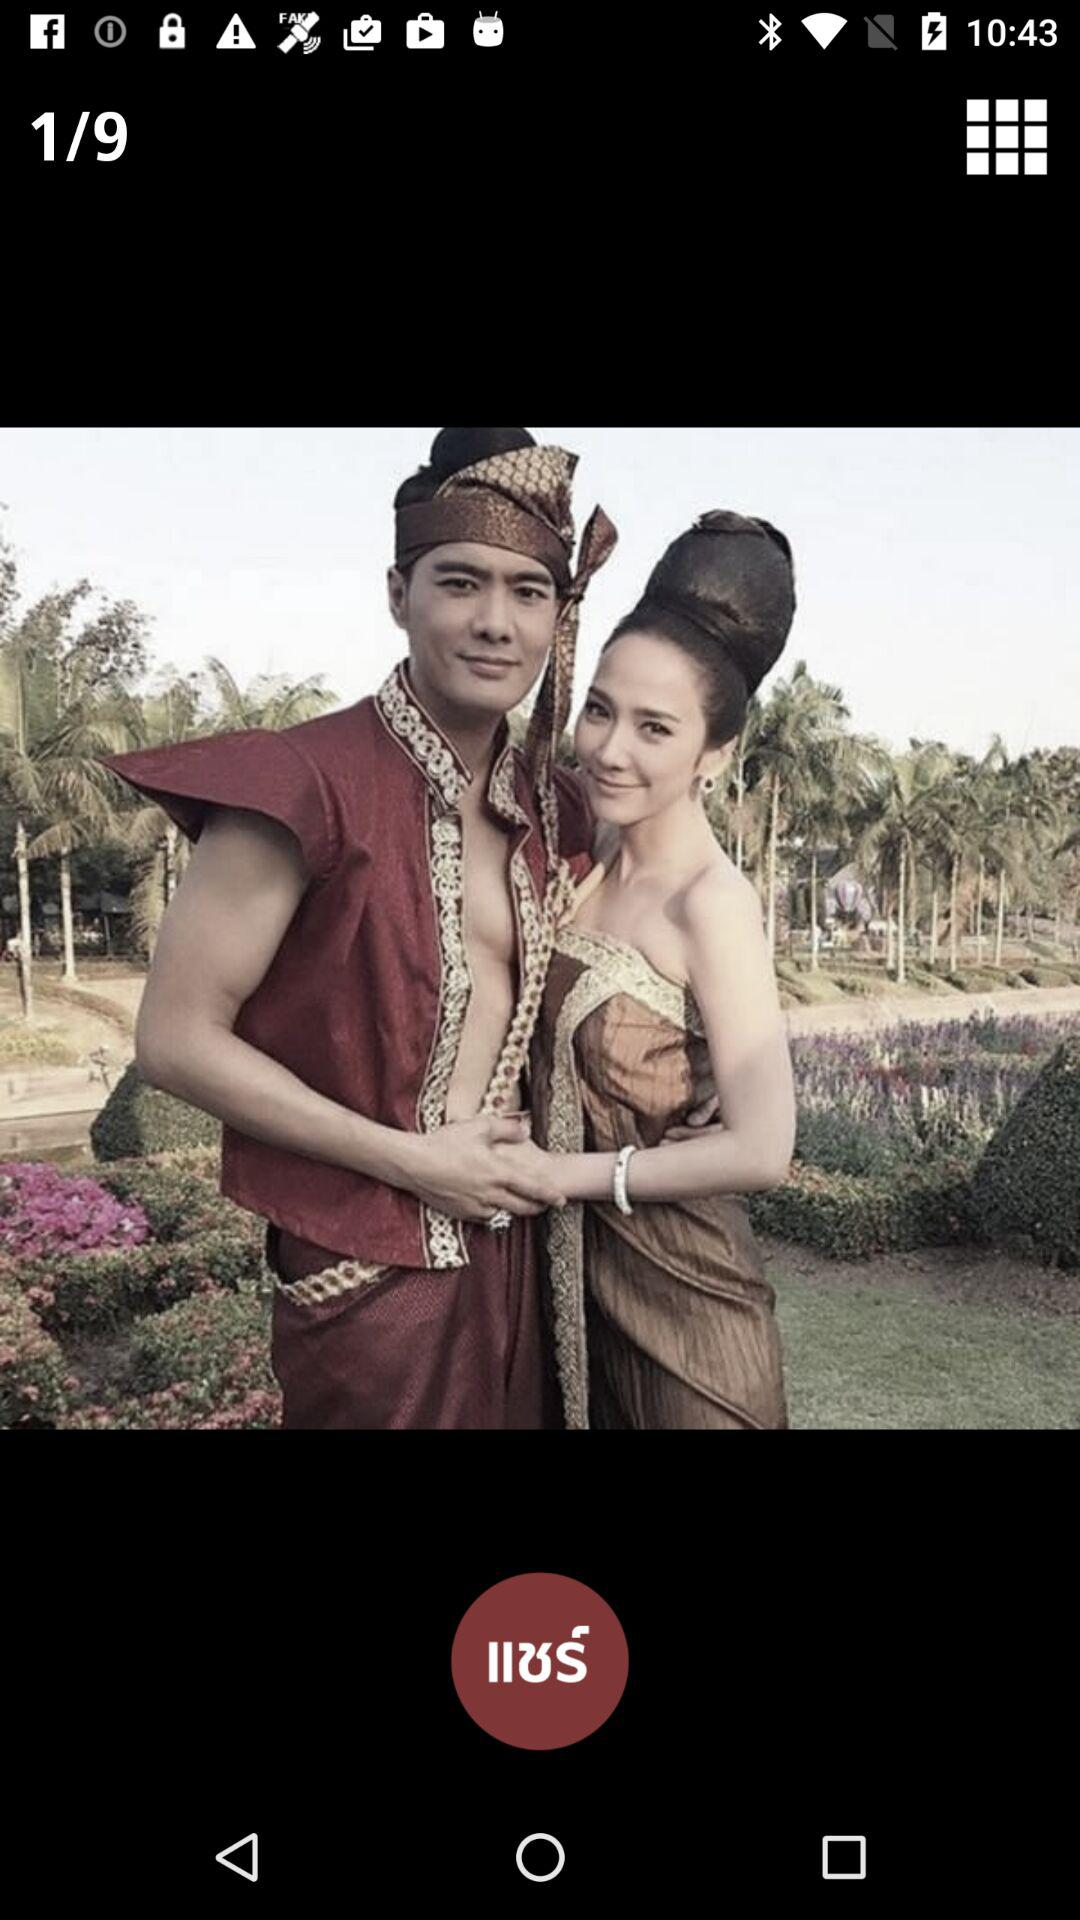What image number is currently shown on the screen? The image number that is currently shown on the screen is 1. 